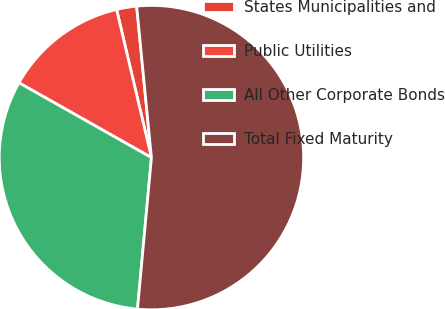Convert chart to OTSL. <chart><loc_0><loc_0><loc_500><loc_500><pie_chart><fcel>States Municipalities and<fcel>Public Utilities<fcel>All Other Corporate Bonds<fcel>Total Fixed Maturity<nl><fcel>2.13%<fcel>13.14%<fcel>31.72%<fcel>53.01%<nl></chart> 